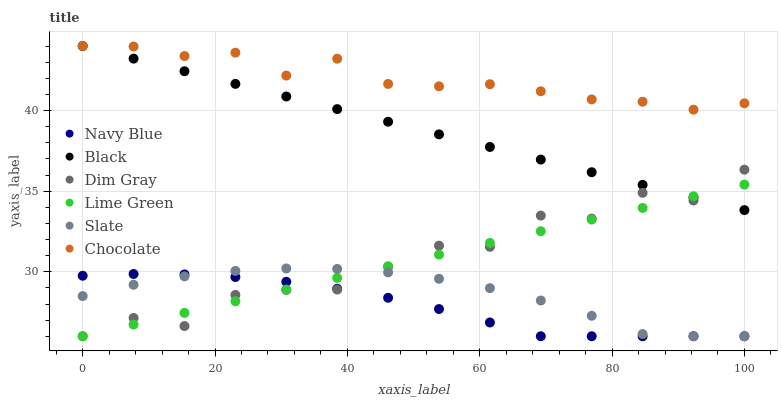Does Navy Blue have the minimum area under the curve?
Answer yes or no. Yes. Does Chocolate have the maximum area under the curve?
Answer yes or no. Yes. Does Slate have the minimum area under the curve?
Answer yes or no. No. Does Slate have the maximum area under the curve?
Answer yes or no. No. Is Lime Green the smoothest?
Answer yes or no. Yes. Is Dim Gray the roughest?
Answer yes or no. Yes. Is Navy Blue the smoothest?
Answer yes or no. No. Is Navy Blue the roughest?
Answer yes or no. No. Does Dim Gray have the lowest value?
Answer yes or no. Yes. Does Chocolate have the lowest value?
Answer yes or no. No. Does Black have the highest value?
Answer yes or no. Yes. Does Slate have the highest value?
Answer yes or no. No. Is Slate less than Chocolate?
Answer yes or no. Yes. Is Black greater than Slate?
Answer yes or no. Yes. Does Slate intersect Dim Gray?
Answer yes or no. Yes. Is Slate less than Dim Gray?
Answer yes or no. No. Is Slate greater than Dim Gray?
Answer yes or no. No. Does Slate intersect Chocolate?
Answer yes or no. No. 